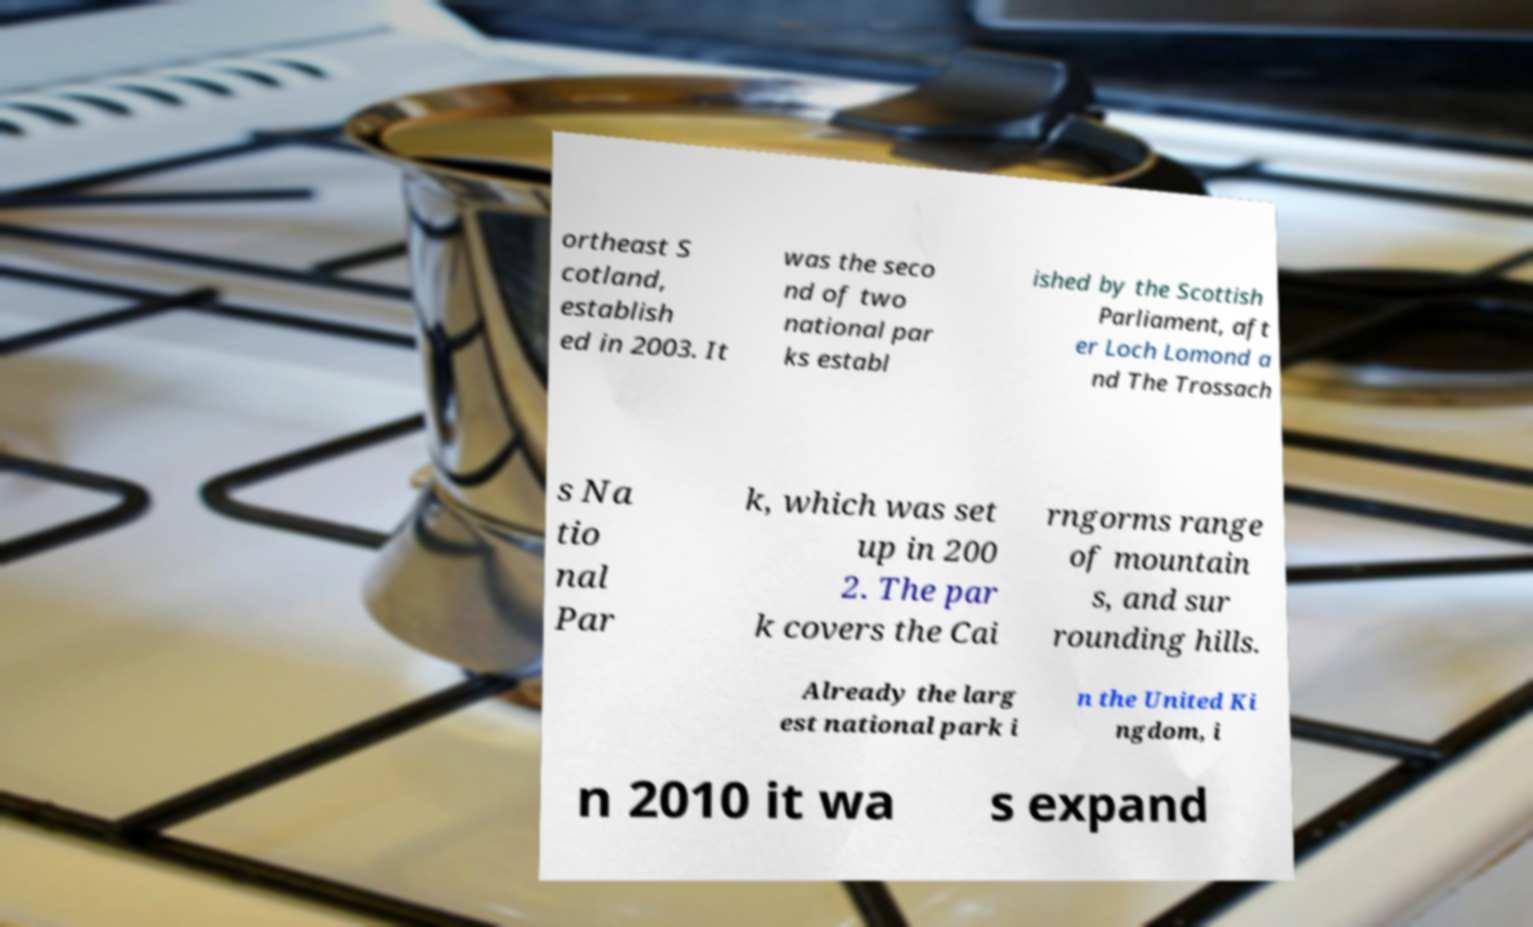I need the written content from this picture converted into text. Can you do that? ortheast S cotland, establish ed in 2003. It was the seco nd of two national par ks establ ished by the Scottish Parliament, aft er Loch Lomond a nd The Trossach s Na tio nal Par k, which was set up in 200 2. The par k covers the Cai rngorms range of mountain s, and sur rounding hills. Already the larg est national park i n the United Ki ngdom, i n 2010 it wa s expand 